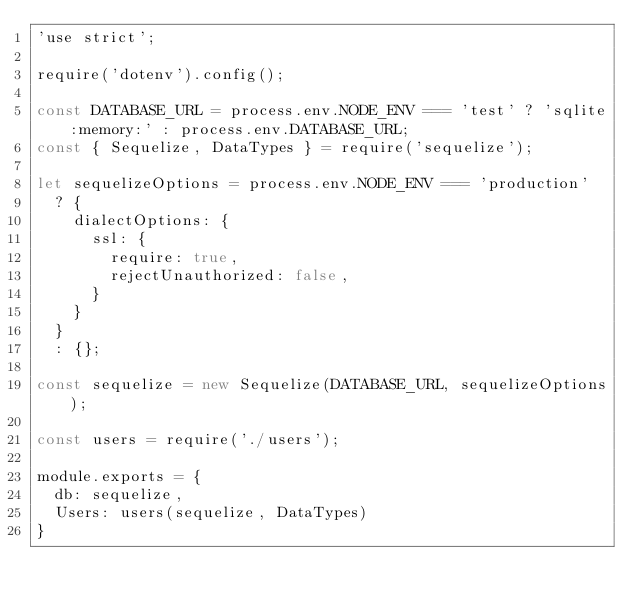<code> <loc_0><loc_0><loc_500><loc_500><_JavaScript_>'use strict';

require('dotenv').config();

const DATABASE_URL = process.env.NODE_ENV === 'test' ? 'sqlite:memory:' : process.env.DATABASE_URL;
const { Sequelize, DataTypes } = require('sequelize');

let sequelizeOptions = process.env.NODE_ENV === 'production'
  ? {
    dialectOptions: {
      ssl: {
        require: true,
        rejectUnauthorized: false,
      }
    }
  }
  : {};

const sequelize = new Sequelize(DATABASE_URL, sequelizeOptions);

const users = require('./users');

module.exports = {
  db: sequelize,
  Users: users(sequelize, DataTypes)
}</code> 